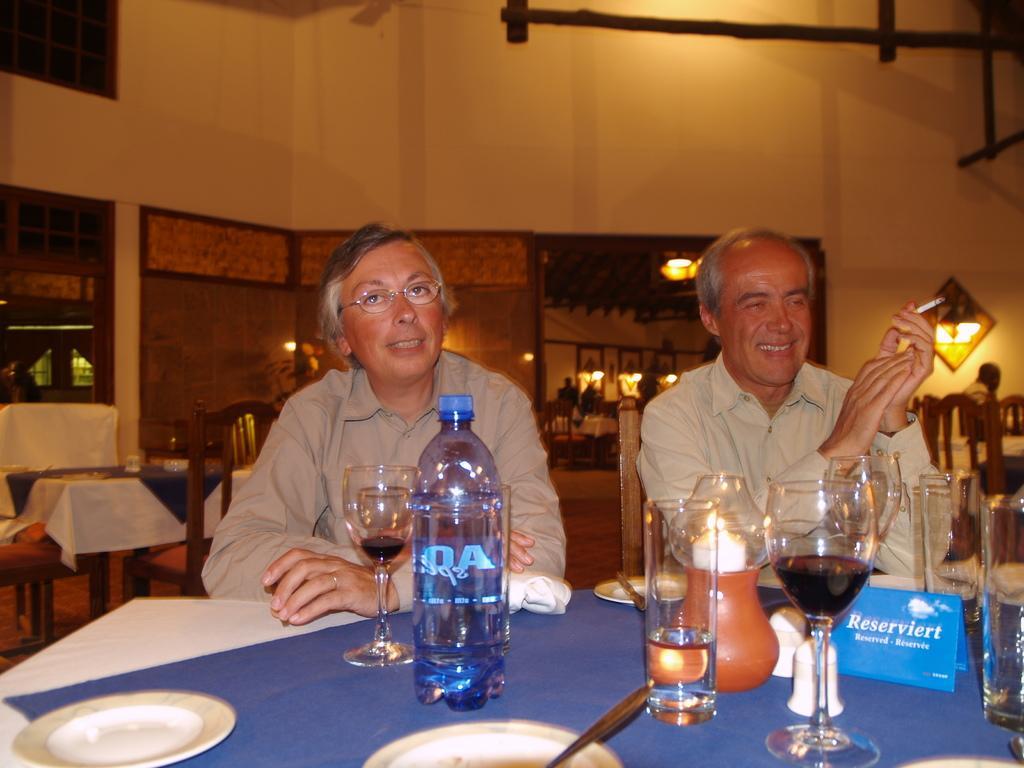Can you describe this image briefly? There are two persons sitting in front of a table which has glass and water bottle on it and the person in the right corner is holding a cigarette in his hand. 